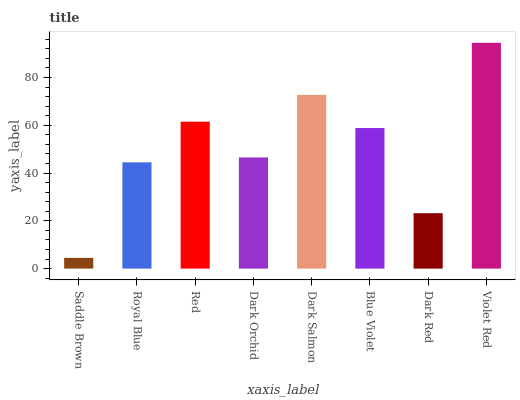Is Saddle Brown the minimum?
Answer yes or no. Yes. Is Violet Red the maximum?
Answer yes or no. Yes. Is Royal Blue the minimum?
Answer yes or no. No. Is Royal Blue the maximum?
Answer yes or no. No. Is Royal Blue greater than Saddle Brown?
Answer yes or no. Yes. Is Saddle Brown less than Royal Blue?
Answer yes or no. Yes. Is Saddle Brown greater than Royal Blue?
Answer yes or no. No. Is Royal Blue less than Saddle Brown?
Answer yes or no. No. Is Blue Violet the high median?
Answer yes or no. Yes. Is Dark Orchid the low median?
Answer yes or no. Yes. Is Violet Red the high median?
Answer yes or no. No. Is Royal Blue the low median?
Answer yes or no. No. 